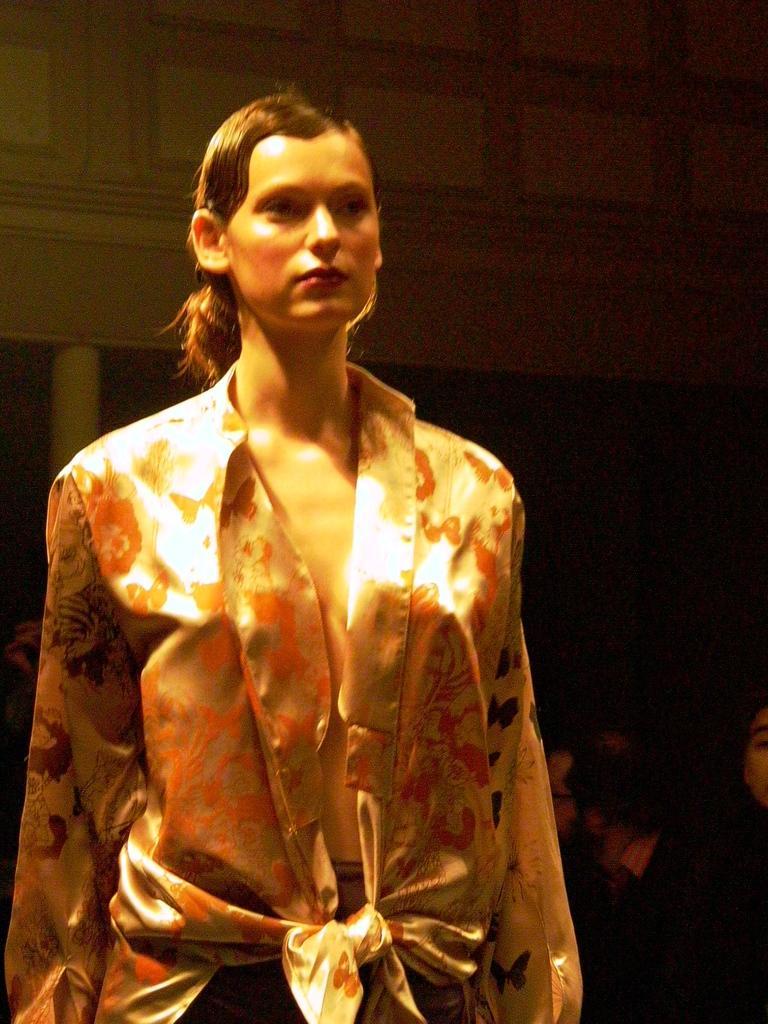Can you describe this image briefly? In this image we can see a woman standing. 